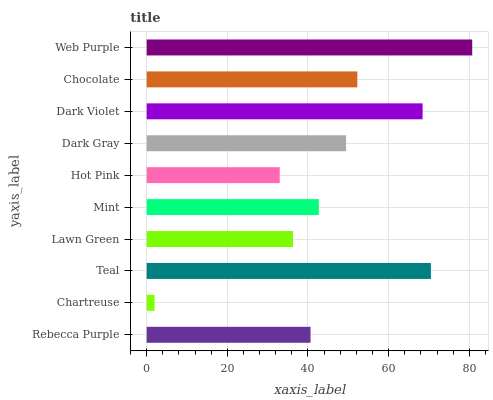Is Chartreuse the minimum?
Answer yes or no. Yes. Is Web Purple the maximum?
Answer yes or no. Yes. Is Teal the minimum?
Answer yes or no. No. Is Teal the maximum?
Answer yes or no. No. Is Teal greater than Chartreuse?
Answer yes or no. Yes. Is Chartreuse less than Teal?
Answer yes or no. Yes. Is Chartreuse greater than Teal?
Answer yes or no. No. Is Teal less than Chartreuse?
Answer yes or no. No. Is Dark Gray the high median?
Answer yes or no. Yes. Is Mint the low median?
Answer yes or no. Yes. Is Web Purple the high median?
Answer yes or no. No. Is Dark Gray the low median?
Answer yes or no. No. 